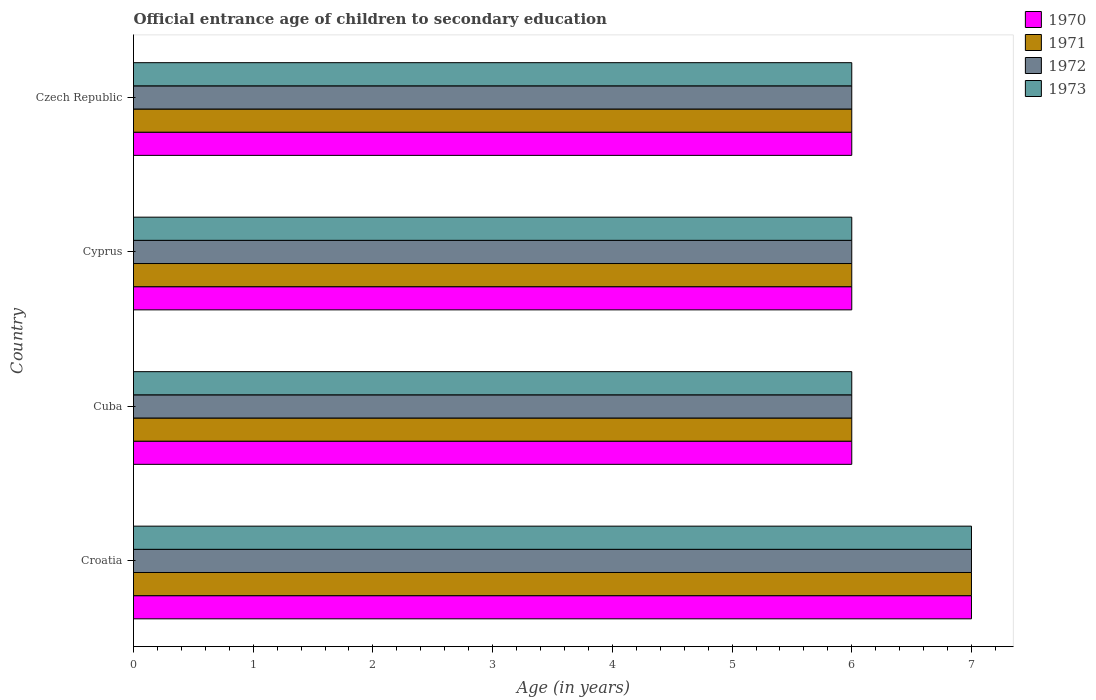How many different coloured bars are there?
Provide a short and direct response. 4. How many bars are there on the 1st tick from the bottom?
Your answer should be very brief. 4. What is the label of the 3rd group of bars from the top?
Keep it short and to the point. Cuba. In how many cases, is the number of bars for a given country not equal to the number of legend labels?
Offer a terse response. 0. What is the secondary school starting age of children in 1970 in Czech Republic?
Give a very brief answer. 6. Across all countries, what is the maximum secondary school starting age of children in 1972?
Provide a short and direct response. 7. In which country was the secondary school starting age of children in 1973 maximum?
Give a very brief answer. Croatia. In which country was the secondary school starting age of children in 1972 minimum?
Your answer should be compact. Cuba. What is the total secondary school starting age of children in 1972 in the graph?
Provide a succinct answer. 25. What is the difference between the secondary school starting age of children in 1970 in Croatia and the secondary school starting age of children in 1971 in Czech Republic?
Provide a succinct answer. 1. What is the average secondary school starting age of children in 1971 per country?
Provide a short and direct response. 6.25. What is the difference between the secondary school starting age of children in 1973 and secondary school starting age of children in 1971 in Cyprus?
Your answer should be compact. 0. In how many countries, is the secondary school starting age of children in 1973 greater than 5.6 years?
Offer a very short reply. 4. What is the ratio of the secondary school starting age of children in 1972 in Croatia to that in Czech Republic?
Ensure brevity in your answer.  1.17. Is the secondary school starting age of children in 1971 in Croatia less than that in Cyprus?
Provide a succinct answer. No. Is the difference between the secondary school starting age of children in 1973 in Cuba and Czech Republic greater than the difference between the secondary school starting age of children in 1971 in Cuba and Czech Republic?
Keep it short and to the point. No. What is the difference between the highest and the lowest secondary school starting age of children in 1972?
Provide a short and direct response. 1. In how many countries, is the secondary school starting age of children in 1971 greater than the average secondary school starting age of children in 1971 taken over all countries?
Offer a very short reply. 1. Is it the case that in every country, the sum of the secondary school starting age of children in 1971 and secondary school starting age of children in 1970 is greater than the sum of secondary school starting age of children in 1972 and secondary school starting age of children in 1973?
Your answer should be very brief. No. What does the 2nd bar from the bottom in Croatia represents?
Your response must be concise. 1971. Is it the case that in every country, the sum of the secondary school starting age of children in 1970 and secondary school starting age of children in 1973 is greater than the secondary school starting age of children in 1972?
Your answer should be compact. Yes. How many bars are there?
Your answer should be very brief. 16. Are the values on the major ticks of X-axis written in scientific E-notation?
Offer a very short reply. No. Does the graph contain any zero values?
Keep it short and to the point. No. Does the graph contain grids?
Give a very brief answer. No. Where does the legend appear in the graph?
Keep it short and to the point. Top right. How many legend labels are there?
Keep it short and to the point. 4. What is the title of the graph?
Your answer should be very brief. Official entrance age of children to secondary education. Does "1994" appear as one of the legend labels in the graph?
Provide a short and direct response. No. What is the label or title of the X-axis?
Keep it short and to the point. Age (in years). What is the label or title of the Y-axis?
Your answer should be very brief. Country. What is the Age (in years) in 1970 in Croatia?
Offer a very short reply. 7. What is the Age (in years) in 1973 in Croatia?
Provide a short and direct response. 7. What is the Age (in years) of 1971 in Cuba?
Make the answer very short. 6. What is the Age (in years) of 1971 in Cyprus?
Your response must be concise. 6. What is the Age (in years) of 1972 in Cyprus?
Your answer should be very brief. 6. What is the Age (in years) of 1973 in Cyprus?
Provide a short and direct response. 6. What is the Age (in years) in 1970 in Czech Republic?
Give a very brief answer. 6. What is the Age (in years) in 1971 in Czech Republic?
Give a very brief answer. 6. What is the Age (in years) in 1972 in Czech Republic?
Ensure brevity in your answer.  6. Across all countries, what is the maximum Age (in years) in 1972?
Ensure brevity in your answer.  7. Across all countries, what is the maximum Age (in years) of 1973?
Offer a terse response. 7. Across all countries, what is the minimum Age (in years) of 1970?
Offer a very short reply. 6. Across all countries, what is the minimum Age (in years) in 1971?
Provide a short and direct response. 6. What is the total Age (in years) of 1971 in the graph?
Ensure brevity in your answer.  25. What is the difference between the Age (in years) of 1970 in Croatia and that in Cuba?
Make the answer very short. 1. What is the difference between the Age (in years) in 1971 in Croatia and that in Cuba?
Keep it short and to the point. 1. What is the difference between the Age (in years) of 1970 in Croatia and that in Cyprus?
Your answer should be very brief. 1. What is the difference between the Age (in years) in 1972 in Croatia and that in Cyprus?
Offer a terse response. 1. What is the difference between the Age (in years) of 1970 in Croatia and that in Czech Republic?
Provide a short and direct response. 1. What is the difference between the Age (in years) in 1971 in Croatia and that in Czech Republic?
Give a very brief answer. 1. What is the difference between the Age (in years) in 1972 in Croatia and that in Czech Republic?
Your answer should be compact. 1. What is the difference between the Age (in years) in 1973 in Croatia and that in Czech Republic?
Provide a short and direct response. 1. What is the difference between the Age (in years) in 1972 in Cuba and that in Cyprus?
Offer a very short reply. 0. What is the difference between the Age (in years) of 1971 in Cuba and that in Czech Republic?
Provide a succinct answer. 0. What is the difference between the Age (in years) of 1972 in Cyprus and that in Czech Republic?
Ensure brevity in your answer.  0. What is the difference between the Age (in years) in 1972 in Croatia and the Age (in years) in 1973 in Cyprus?
Keep it short and to the point. 1. What is the difference between the Age (in years) of 1970 in Croatia and the Age (in years) of 1971 in Czech Republic?
Keep it short and to the point. 1. What is the difference between the Age (in years) of 1970 in Croatia and the Age (in years) of 1973 in Czech Republic?
Offer a very short reply. 1. What is the difference between the Age (in years) in 1971 in Croatia and the Age (in years) in 1972 in Czech Republic?
Give a very brief answer. 1. What is the difference between the Age (in years) of 1972 in Croatia and the Age (in years) of 1973 in Czech Republic?
Make the answer very short. 1. What is the difference between the Age (in years) of 1970 in Cuba and the Age (in years) of 1973 in Cyprus?
Make the answer very short. 0. What is the difference between the Age (in years) in 1971 in Cuba and the Age (in years) in 1972 in Cyprus?
Keep it short and to the point. 0. What is the difference between the Age (in years) of 1970 in Cuba and the Age (in years) of 1971 in Czech Republic?
Keep it short and to the point. 0. What is the difference between the Age (in years) of 1970 in Cuba and the Age (in years) of 1973 in Czech Republic?
Make the answer very short. 0. What is the difference between the Age (in years) in 1971 in Cuba and the Age (in years) in 1973 in Czech Republic?
Offer a terse response. 0. What is the difference between the Age (in years) in 1970 in Cyprus and the Age (in years) in 1971 in Czech Republic?
Make the answer very short. 0. What is the difference between the Age (in years) in 1970 in Cyprus and the Age (in years) in 1973 in Czech Republic?
Give a very brief answer. 0. What is the difference between the Age (in years) of 1971 in Cyprus and the Age (in years) of 1972 in Czech Republic?
Ensure brevity in your answer.  0. What is the difference between the Age (in years) in 1971 in Cyprus and the Age (in years) in 1973 in Czech Republic?
Keep it short and to the point. 0. What is the average Age (in years) of 1970 per country?
Offer a terse response. 6.25. What is the average Age (in years) of 1971 per country?
Keep it short and to the point. 6.25. What is the average Age (in years) in 1972 per country?
Offer a very short reply. 6.25. What is the average Age (in years) in 1973 per country?
Give a very brief answer. 6.25. What is the difference between the Age (in years) of 1970 and Age (in years) of 1972 in Croatia?
Your response must be concise. 0. What is the difference between the Age (in years) in 1970 and Age (in years) in 1971 in Cuba?
Keep it short and to the point. 0. What is the difference between the Age (in years) in 1970 and Age (in years) in 1972 in Cuba?
Provide a short and direct response. 0. What is the difference between the Age (in years) of 1970 and Age (in years) of 1973 in Cuba?
Your response must be concise. 0. What is the difference between the Age (in years) of 1970 and Age (in years) of 1973 in Cyprus?
Ensure brevity in your answer.  0. What is the difference between the Age (in years) in 1971 and Age (in years) in 1972 in Cyprus?
Your response must be concise. 0. What is the difference between the Age (in years) of 1972 and Age (in years) of 1973 in Cyprus?
Your answer should be very brief. 0. What is the difference between the Age (in years) in 1970 and Age (in years) in 1971 in Czech Republic?
Your answer should be very brief. 0. What is the difference between the Age (in years) in 1970 and Age (in years) in 1972 in Czech Republic?
Your answer should be compact. 0. What is the difference between the Age (in years) in 1971 and Age (in years) in 1972 in Czech Republic?
Give a very brief answer. 0. What is the difference between the Age (in years) of 1971 and Age (in years) of 1973 in Czech Republic?
Provide a short and direct response. 0. What is the difference between the Age (in years) in 1972 and Age (in years) in 1973 in Czech Republic?
Give a very brief answer. 0. What is the ratio of the Age (in years) in 1970 in Croatia to that in Cuba?
Give a very brief answer. 1.17. What is the ratio of the Age (in years) of 1971 in Croatia to that in Cuba?
Your answer should be compact. 1.17. What is the ratio of the Age (in years) in 1972 in Croatia to that in Cuba?
Offer a terse response. 1.17. What is the ratio of the Age (in years) of 1973 in Croatia to that in Cuba?
Offer a very short reply. 1.17. What is the ratio of the Age (in years) in 1970 in Croatia to that in Cyprus?
Your answer should be very brief. 1.17. What is the ratio of the Age (in years) of 1972 in Croatia to that in Czech Republic?
Provide a short and direct response. 1.17. What is the ratio of the Age (in years) of 1970 in Cuba to that in Cyprus?
Your answer should be compact. 1. What is the ratio of the Age (in years) in 1972 in Cuba to that in Cyprus?
Offer a very short reply. 1. What is the ratio of the Age (in years) in 1970 in Cuba to that in Czech Republic?
Provide a short and direct response. 1. What is the ratio of the Age (in years) of 1971 in Cuba to that in Czech Republic?
Your response must be concise. 1. What is the ratio of the Age (in years) of 1972 in Cuba to that in Czech Republic?
Offer a very short reply. 1. What is the ratio of the Age (in years) in 1973 in Cuba to that in Czech Republic?
Provide a succinct answer. 1. What is the ratio of the Age (in years) of 1970 in Cyprus to that in Czech Republic?
Make the answer very short. 1. What is the ratio of the Age (in years) of 1972 in Cyprus to that in Czech Republic?
Give a very brief answer. 1. What is the ratio of the Age (in years) in 1973 in Cyprus to that in Czech Republic?
Ensure brevity in your answer.  1. What is the difference between the highest and the lowest Age (in years) in 1970?
Your answer should be compact. 1. What is the difference between the highest and the lowest Age (in years) in 1973?
Provide a short and direct response. 1. 